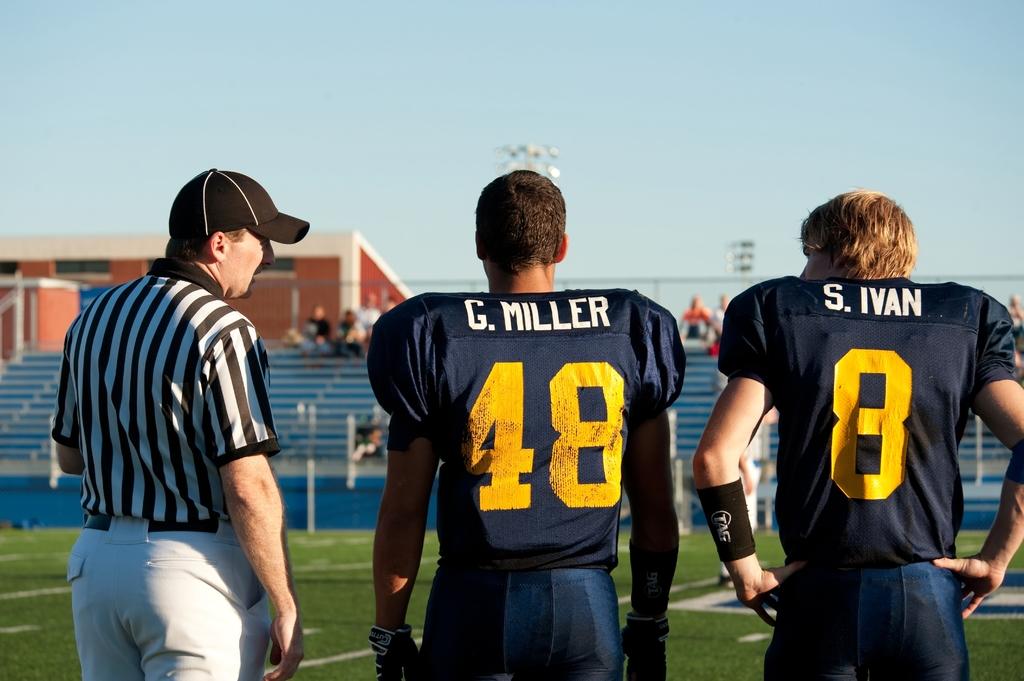What is the person's name who is standing in the middle?
Your answer should be compact. G. miller. What number is the middle player?
Offer a terse response. 48. 